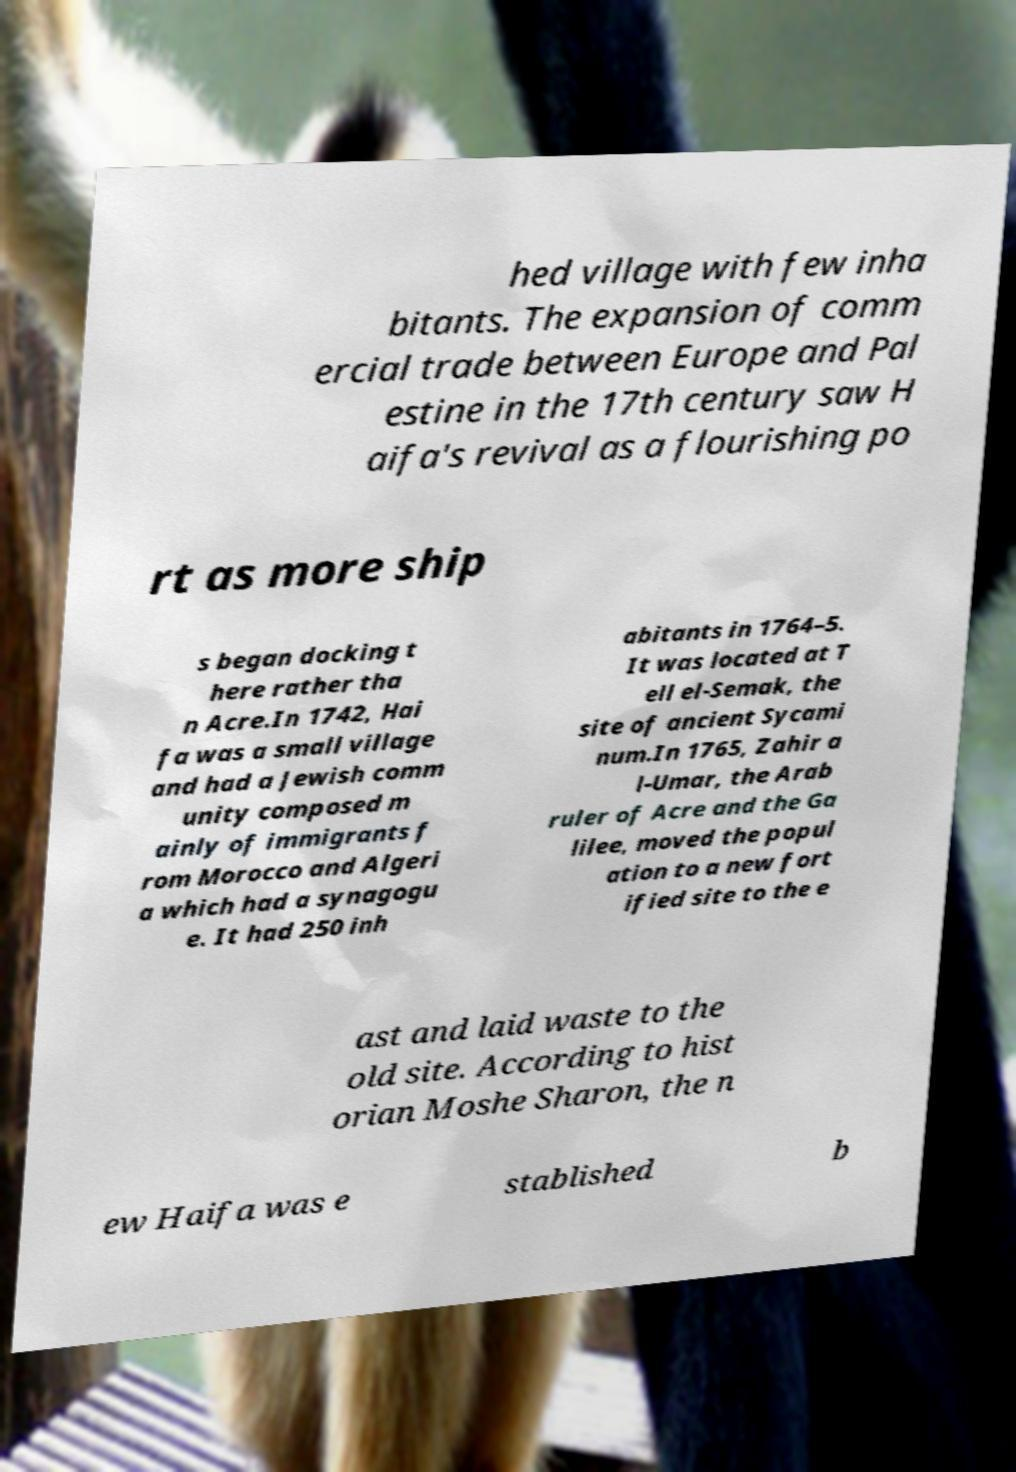Can you accurately transcribe the text from the provided image for me? hed village with few inha bitants. The expansion of comm ercial trade between Europe and Pal estine in the 17th century saw H aifa's revival as a flourishing po rt as more ship s began docking t here rather tha n Acre.In 1742, Hai fa was a small village and had a Jewish comm unity composed m ainly of immigrants f rom Morocco and Algeri a which had a synagogu e. It had 250 inh abitants in 1764–5. It was located at T ell el-Semak, the site of ancient Sycami num.In 1765, Zahir a l-Umar, the Arab ruler of Acre and the Ga lilee, moved the popul ation to a new fort ified site to the e ast and laid waste to the old site. According to hist orian Moshe Sharon, the n ew Haifa was e stablished b 